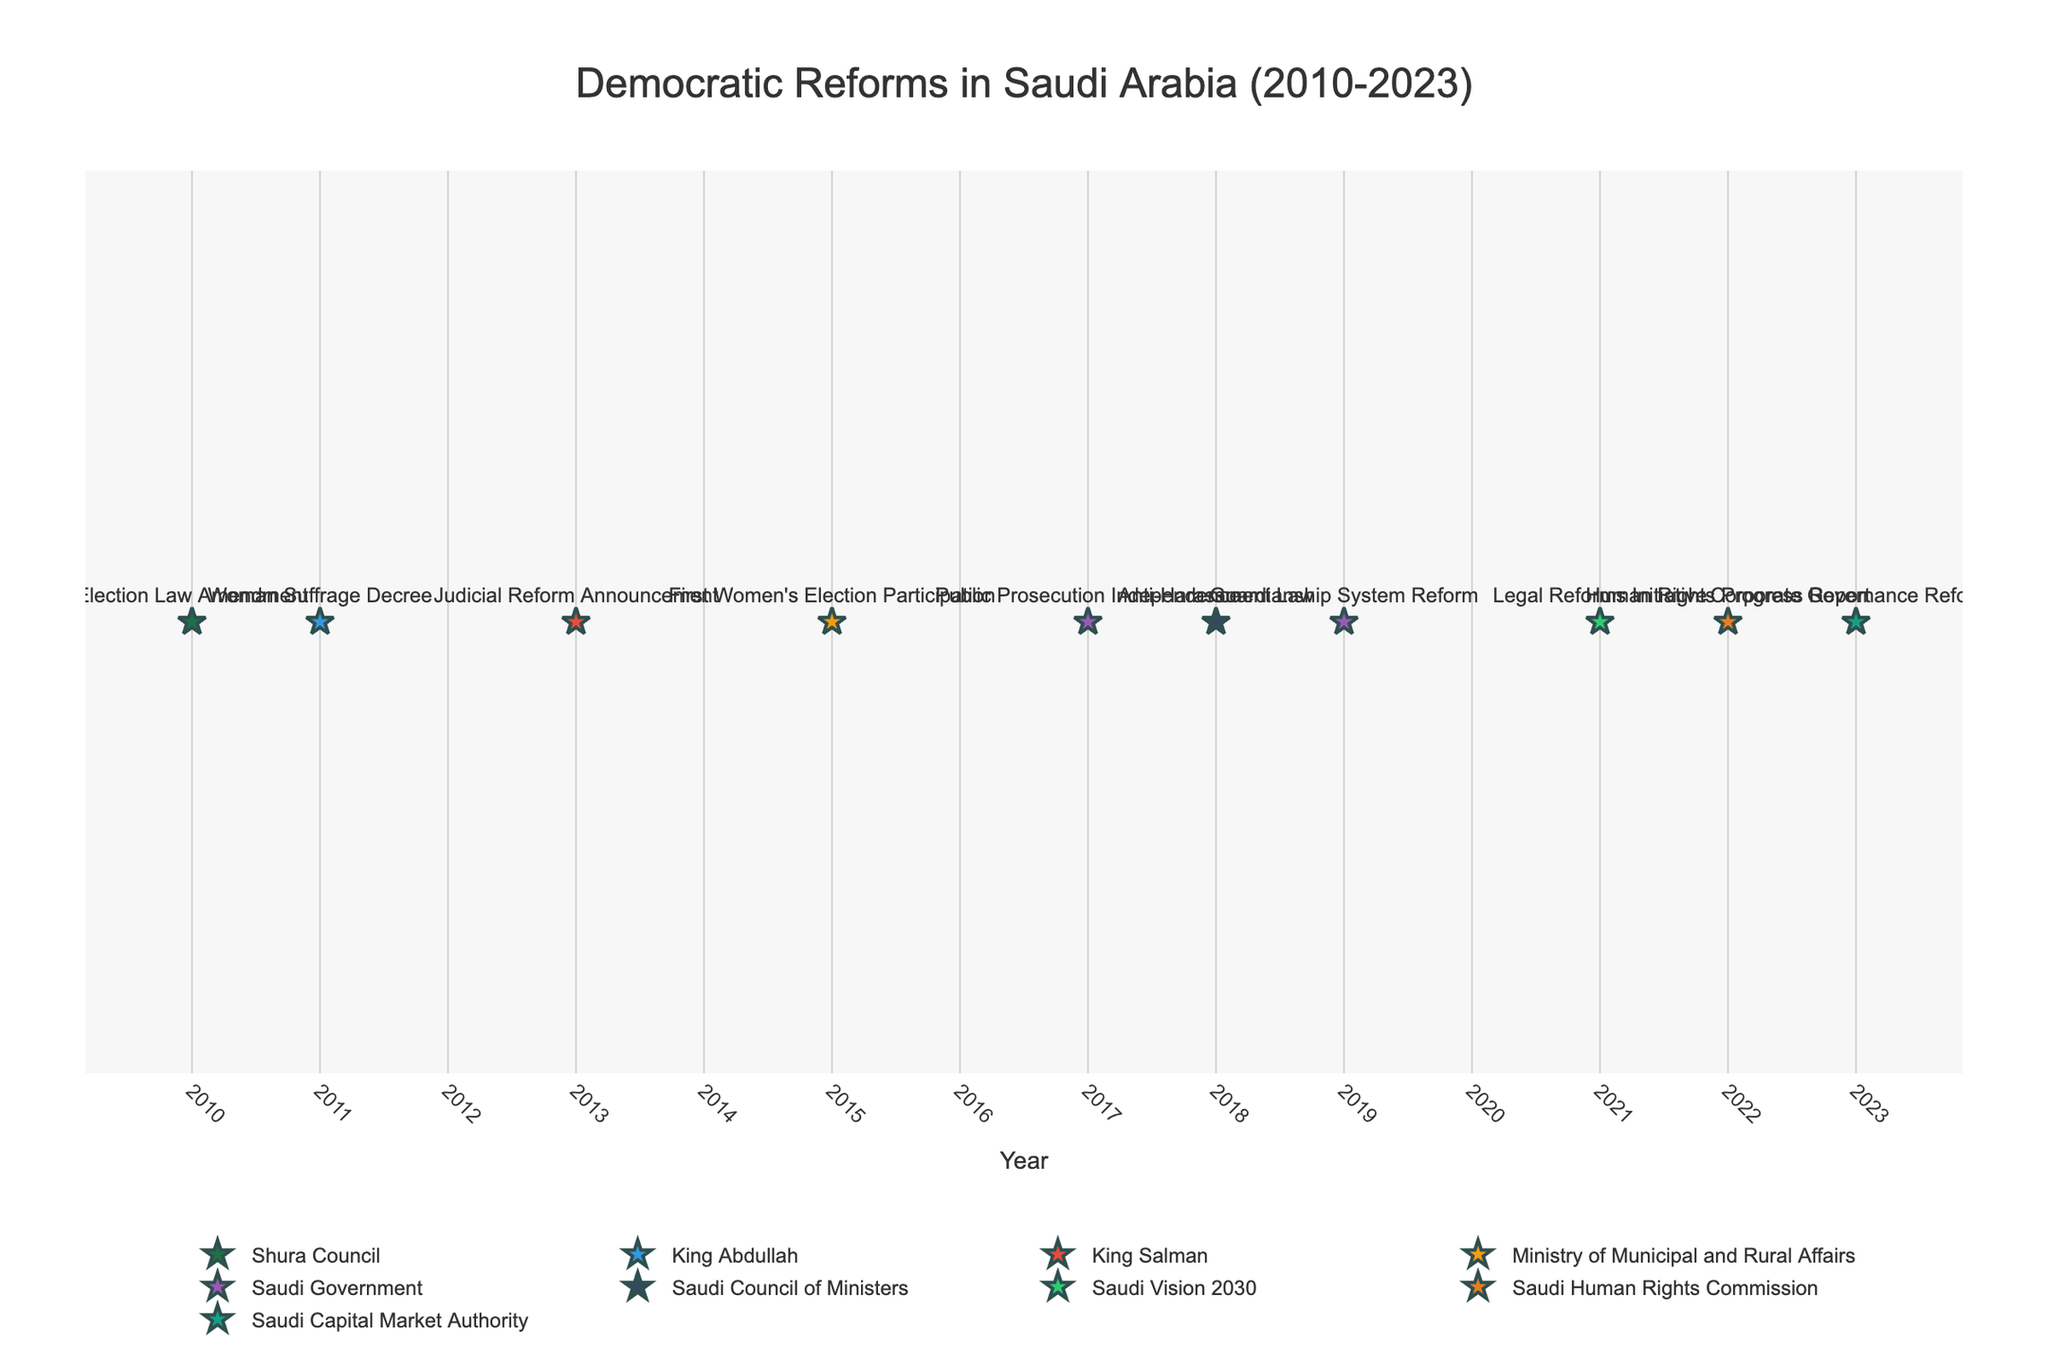what is the title of the plot? The title of the plot is usually located at the top and center of the figure. The text in the title summarizes the main topic the plot is presenting. In this case, the title reads "Democratic Reforms in Saudi Arabia (2010-2023)."
Answer: Democratic Reforms in Saudi Arabia (2010-2023) How many amendments or developments are shown in the plot? To determine the number of amendments or developments, we count the number of data points (markers) present in the plot. Each marker represents one amendment or development. According to the data, there are 10 such points from 2010 to 2023.
Answer: 10 Which year had the first recorded amendment or development in the legal framework? To find the first recorded amendment, look for the earliest year on the x-axis that has a data point. In this case, the plot shows data points starting from the year 2010.
Answer: 2010 Which entity was responsible for the most amendments or developments? To determine which entity had the most contributions, look for the entities with the greatest number of markers. By checking the plot or legend, you will see that 'Saudi Government' has three data points, the highest among all entities.
Answer: Saudi Government Which year had the highest number of different entities making amendments or developments? To identify this, count the number of distinct markers (representing different entities) in each year. The year with the most distinct entities is 2019, where multiple entities like 'Saudi Government,' 'Saudi Council of Ministers,' etc., were active.
Answer: 2019 Did women gain any specific rights in any of the amendments or developments shown? If so, in which year? By examining the hovertext associated with each marker, look for descriptions mentioning women's rights. The plot shows markers in 2011 ('Woman Suffrage Decree') and 2015 ('First Women's Election Participation'), and 2019 ('Guardianship System Reform') related to women gaining specific rights.
Answer: 2011, 2015, 2019 Which amendment or development had the most significant implications for judicial transparency? Reviewing the hovertext of the markers for terms related to judicial processes, 'Judicial Reform Announcement' in 2013 and 'Legal Reforms Initiative' in 2021 both aim to improve judicial transparency. However, the 'Judicial Reform Announcement' is particularly focused on creating specialized courts.
Answer: 2013 Compare the number of amendments by 'King Abdullah' and 'King Salman.' Sum up the number of markers attributed to each leader. From the plot, 'King Abdullah' is associated with one amendment in 2011, while 'King Salman' has one in 2013. The quantities are equal.
Answer: Equal, 1 each Which development pertains to improving corporate transparency? Look through the hovertext associated with each year for mentions of corporate transparency. The year 2023 has 'Corporate Governance Reforms' aiming to improve corporate transparency.
Answer: 2023 